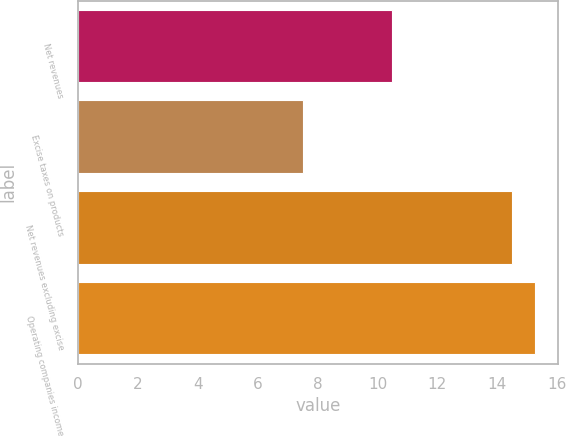Convert chart. <chart><loc_0><loc_0><loc_500><loc_500><bar_chart><fcel>Net revenues<fcel>Excise taxes on products<fcel>Net revenues excluding excise<fcel>Operating companies income<nl><fcel>10.5<fcel>7.5<fcel>14.5<fcel>15.26<nl></chart> 